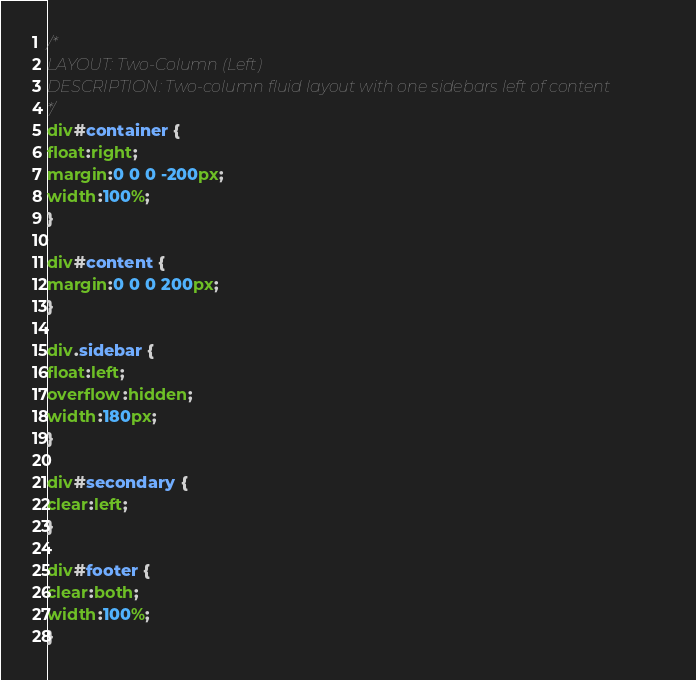Convert code to text. <code><loc_0><loc_0><loc_500><loc_500><_CSS_>/*
LAYOUT: Two-Column (Left)
DESCRIPTION: Two-column fluid layout with one sidebars left of content
*/
div#container {
float:right;
margin:0 0 0 -200px;
width:100%;
}

div#content {
margin:0 0 0 200px;
}

div.sidebar {
float:left;
overflow:hidden;
width:180px;
}

div#secondary {
clear:left;
}

div#footer {
clear:both;
width:100%;
}</code> 